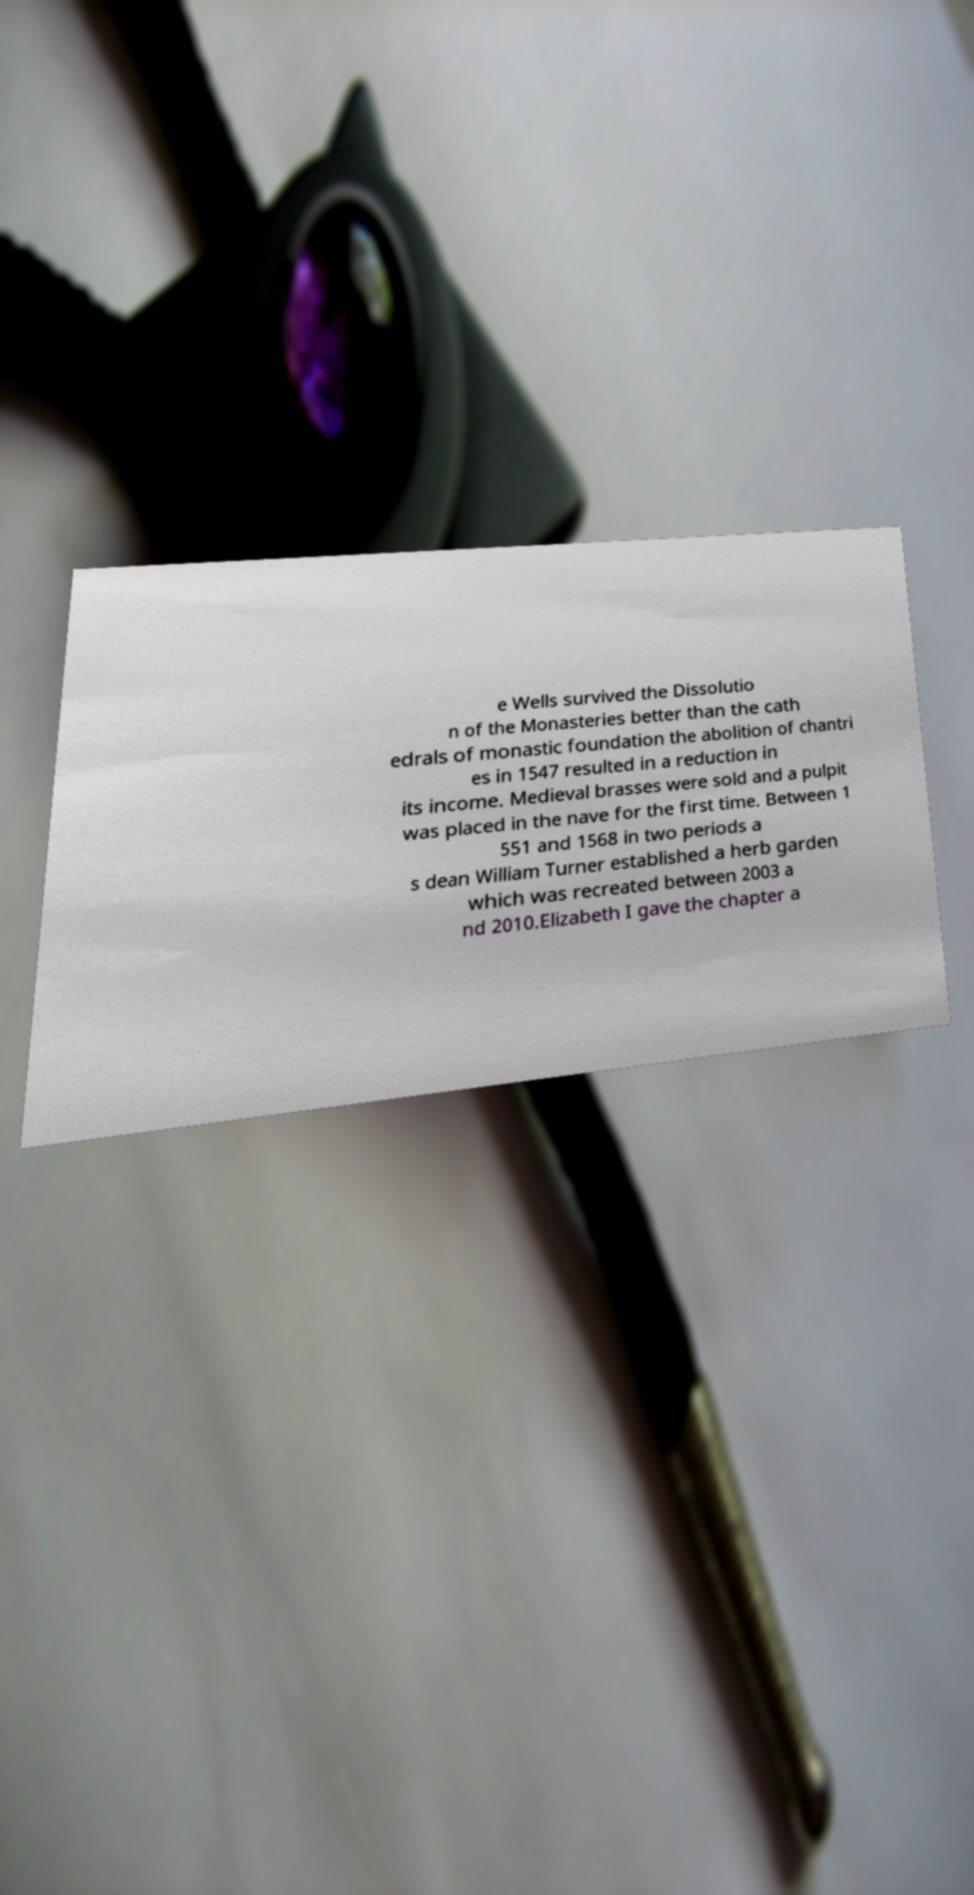Could you extract and type out the text from this image? e Wells survived the Dissolutio n of the Monasteries better than the cath edrals of monastic foundation the abolition of chantri es in 1547 resulted in a reduction in its income. Medieval brasses were sold and a pulpit was placed in the nave for the first time. Between 1 551 and 1568 in two periods a s dean William Turner established a herb garden which was recreated between 2003 a nd 2010.Elizabeth I gave the chapter a 